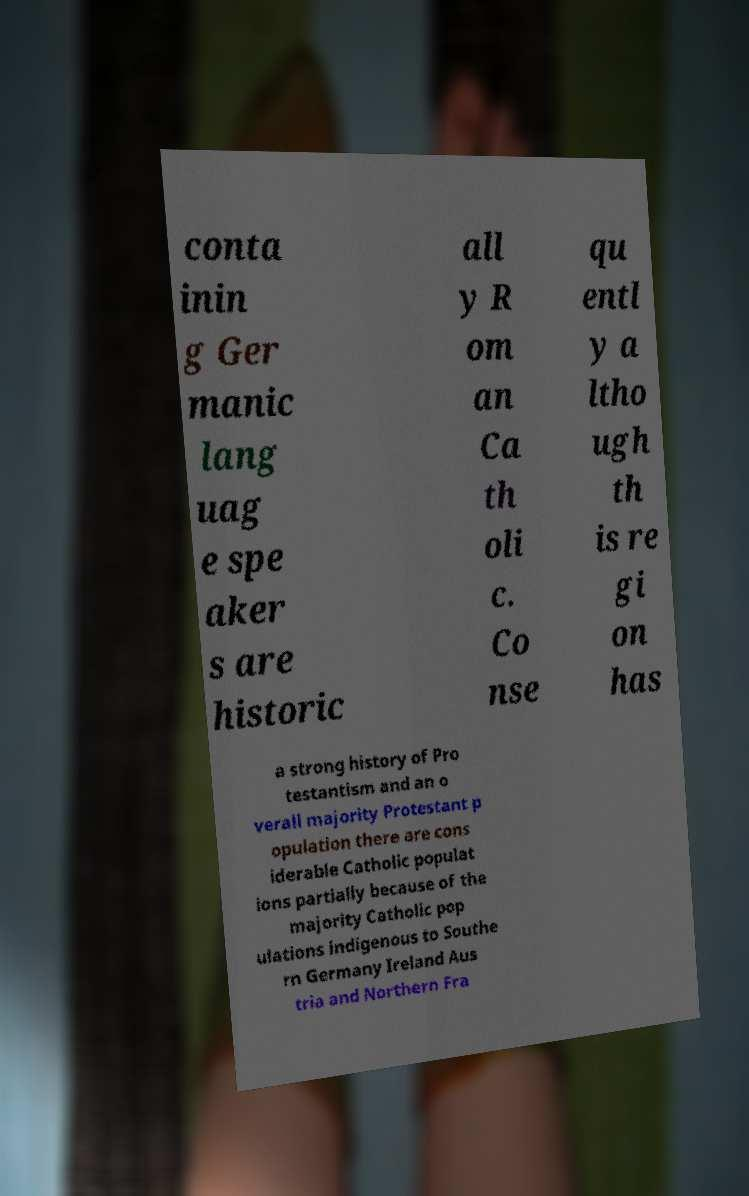Can you accurately transcribe the text from the provided image for me? conta inin g Ger manic lang uag e spe aker s are historic all y R om an Ca th oli c. Co nse qu entl y a ltho ugh th is re gi on has a strong history of Pro testantism and an o verall majority Protestant p opulation there are cons iderable Catholic populat ions partially because of the majority Catholic pop ulations indigenous to Southe rn Germany Ireland Aus tria and Northern Fra 